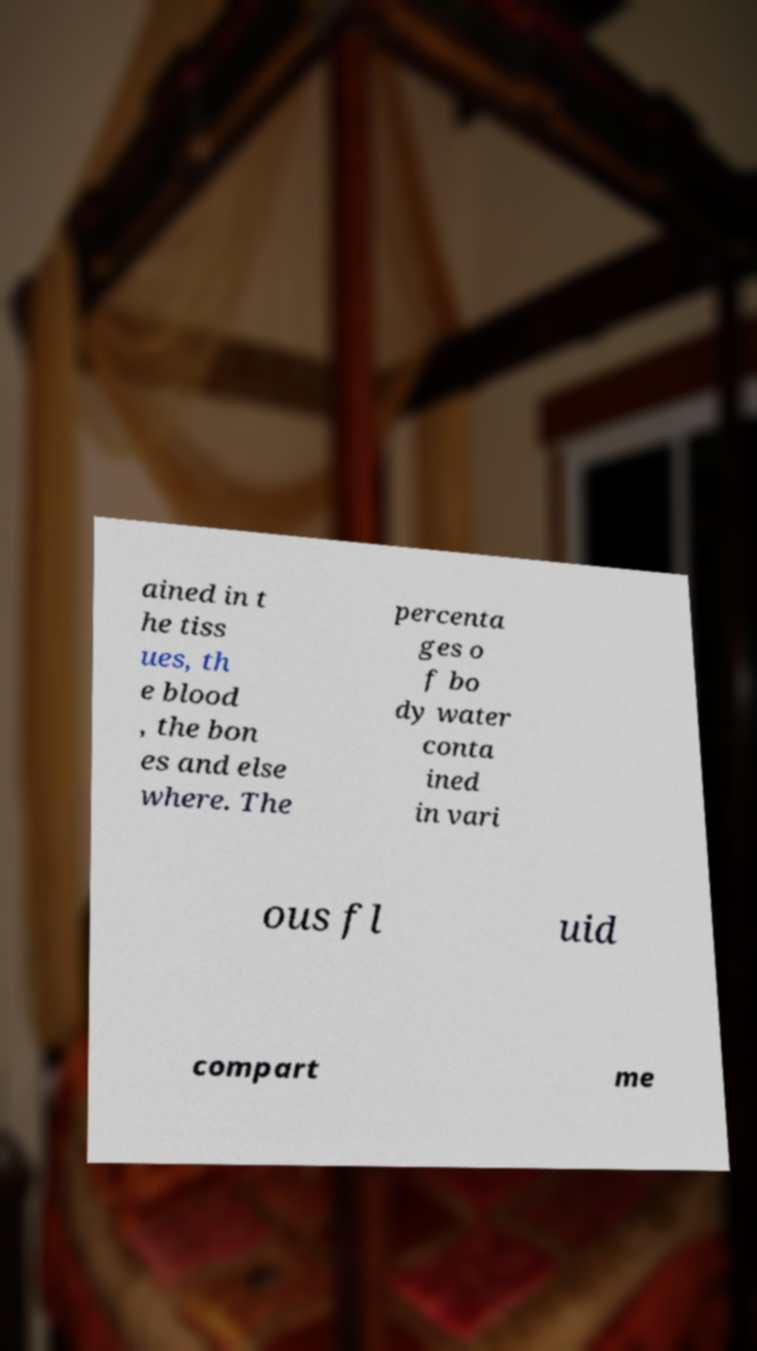For documentation purposes, I need the text within this image transcribed. Could you provide that? ained in t he tiss ues, th e blood , the bon es and else where. The percenta ges o f bo dy water conta ined in vari ous fl uid compart me 